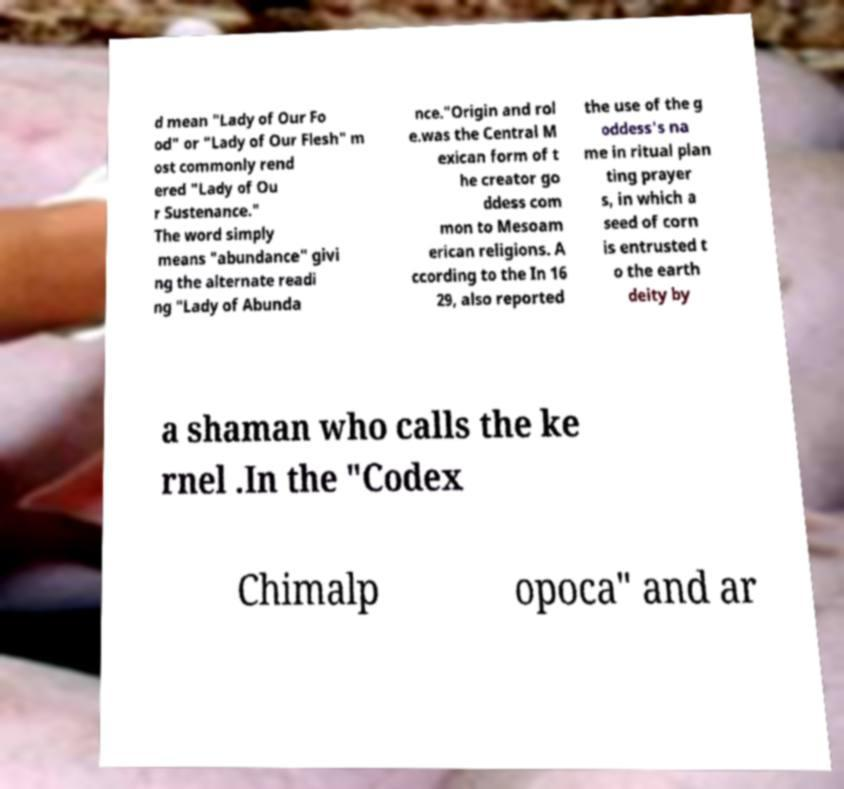I need the written content from this picture converted into text. Can you do that? d mean "Lady of Our Fo od" or "Lady of Our Flesh" m ost commonly rend ered "Lady of Ou r Sustenance." The word simply means "abundance" givi ng the alternate readi ng "Lady of Abunda nce."Origin and rol e.was the Central M exican form of t he creator go ddess com mon to Mesoam erican religions. A ccording to the In 16 29, also reported the use of the g oddess's na me in ritual plan ting prayer s, in which a seed of corn is entrusted t o the earth deity by a shaman who calls the ke rnel .In the "Codex Chimalp opoca" and ar 